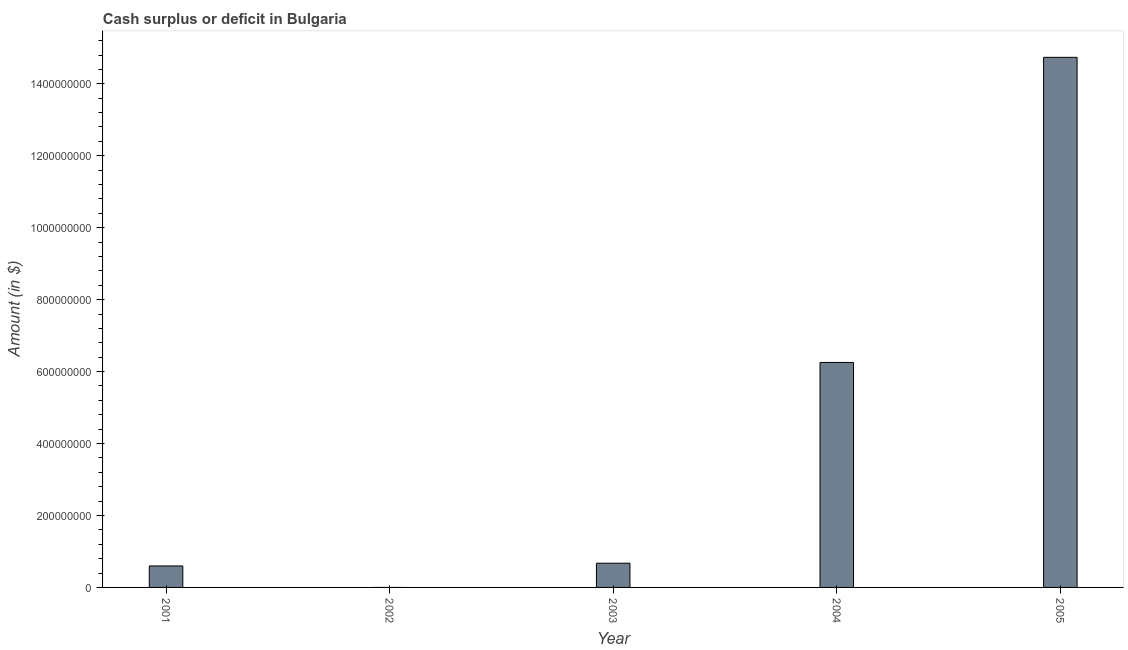Does the graph contain grids?
Your answer should be very brief. No. What is the title of the graph?
Provide a succinct answer. Cash surplus or deficit in Bulgaria. What is the label or title of the Y-axis?
Your response must be concise. Amount (in $). What is the cash surplus or deficit in 2005?
Your answer should be compact. 1.47e+09. Across all years, what is the maximum cash surplus or deficit?
Ensure brevity in your answer.  1.47e+09. What is the sum of the cash surplus or deficit?
Offer a very short reply. 2.23e+09. What is the difference between the cash surplus or deficit in 2003 and 2005?
Keep it short and to the point. -1.41e+09. What is the average cash surplus or deficit per year?
Make the answer very short. 4.45e+08. What is the median cash surplus or deficit?
Your response must be concise. 6.74e+07. What is the ratio of the cash surplus or deficit in 2003 to that in 2004?
Keep it short and to the point. 0.11. Is the cash surplus or deficit in 2001 less than that in 2004?
Your answer should be very brief. Yes. Is the difference between the cash surplus or deficit in 2001 and 2005 greater than the difference between any two years?
Your response must be concise. No. What is the difference between the highest and the second highest cash surplus or deficit?
Keep it short and to the point. 8.48e+08. What is the difference between the highest and the lowest cash surplus or deficit?
Your answer should be very brief. 1.47e+09. In how many years, is the cash surplus or deficit greater than the average cash surplus or deficit taken over all years?
Your answer should be compact. 2. How many bars are there?
Your response must be concise. 4. Are all the bars in the graph horizontal?
Keep it short and to the point. No. What is the difference between two consecutive major ticks on the Y-axis?
Provide a succinct answer. 2.00e+08. What is the Amount (in $) of 2001?
Offer a very short reply. 5.97e+07. What is the Amount (in $) of 2002?
Your answer should be compact. 0. What is the Amount (in $) in 2003?
Give a very brief answer. 6.74e+07. What is the Amount (in $) of 2004?
Give a very brief answer. 6.25e+08. What is the Amount (in $) of 2005?
Keep it short and to the point. 1.47e+09. What is the difference between the Amount (in $) in 2001 and 2003?
Offer a very short reply. -7.65e+06. What is the difference between the Amount (in $) in 2001 and 2004?
Ensure brevity in your answer.  -5.66e+08. What is the difference between the Amount (in $) in 2001 and 2005?
Your answer should be very brief. -1.41e+09. What is the difference between the Amount (in $) in 2003 and 2004?
Ensure brevity in your answer.  -5.58e+08. What is the difference between the Amount (in $) in 2003 and 2005?
Ensure brevity in your answer.  -1.41e+09. What is the difference between the Amount (in $) in 2004 and 2005?
Ensure brevity in your answer.  -8.48e+08. What is the ratio of the Amount (in $) in 2001 to that in 2003?
Your response must be concise. 0.89. What is the ratio of the Amount (in $) in 2001 to that in 2004?
Give a very brief answer. 0.1. What is the ratio of the Amount (in $) in 2001 to that in 2005?
Your response must be concise. 0.04. What is the ratio of the Amount (in $) in 2003 to that in 2004?
Make the answer very short. 0.11. What is the ratio of the Amount (in $) in 2003 to that in 2005?
Offer a terse response. 0.05. What is the ratio of the Amount (in $) in 2004 to that in 2005?
Give a very brief answer. 0.42. 